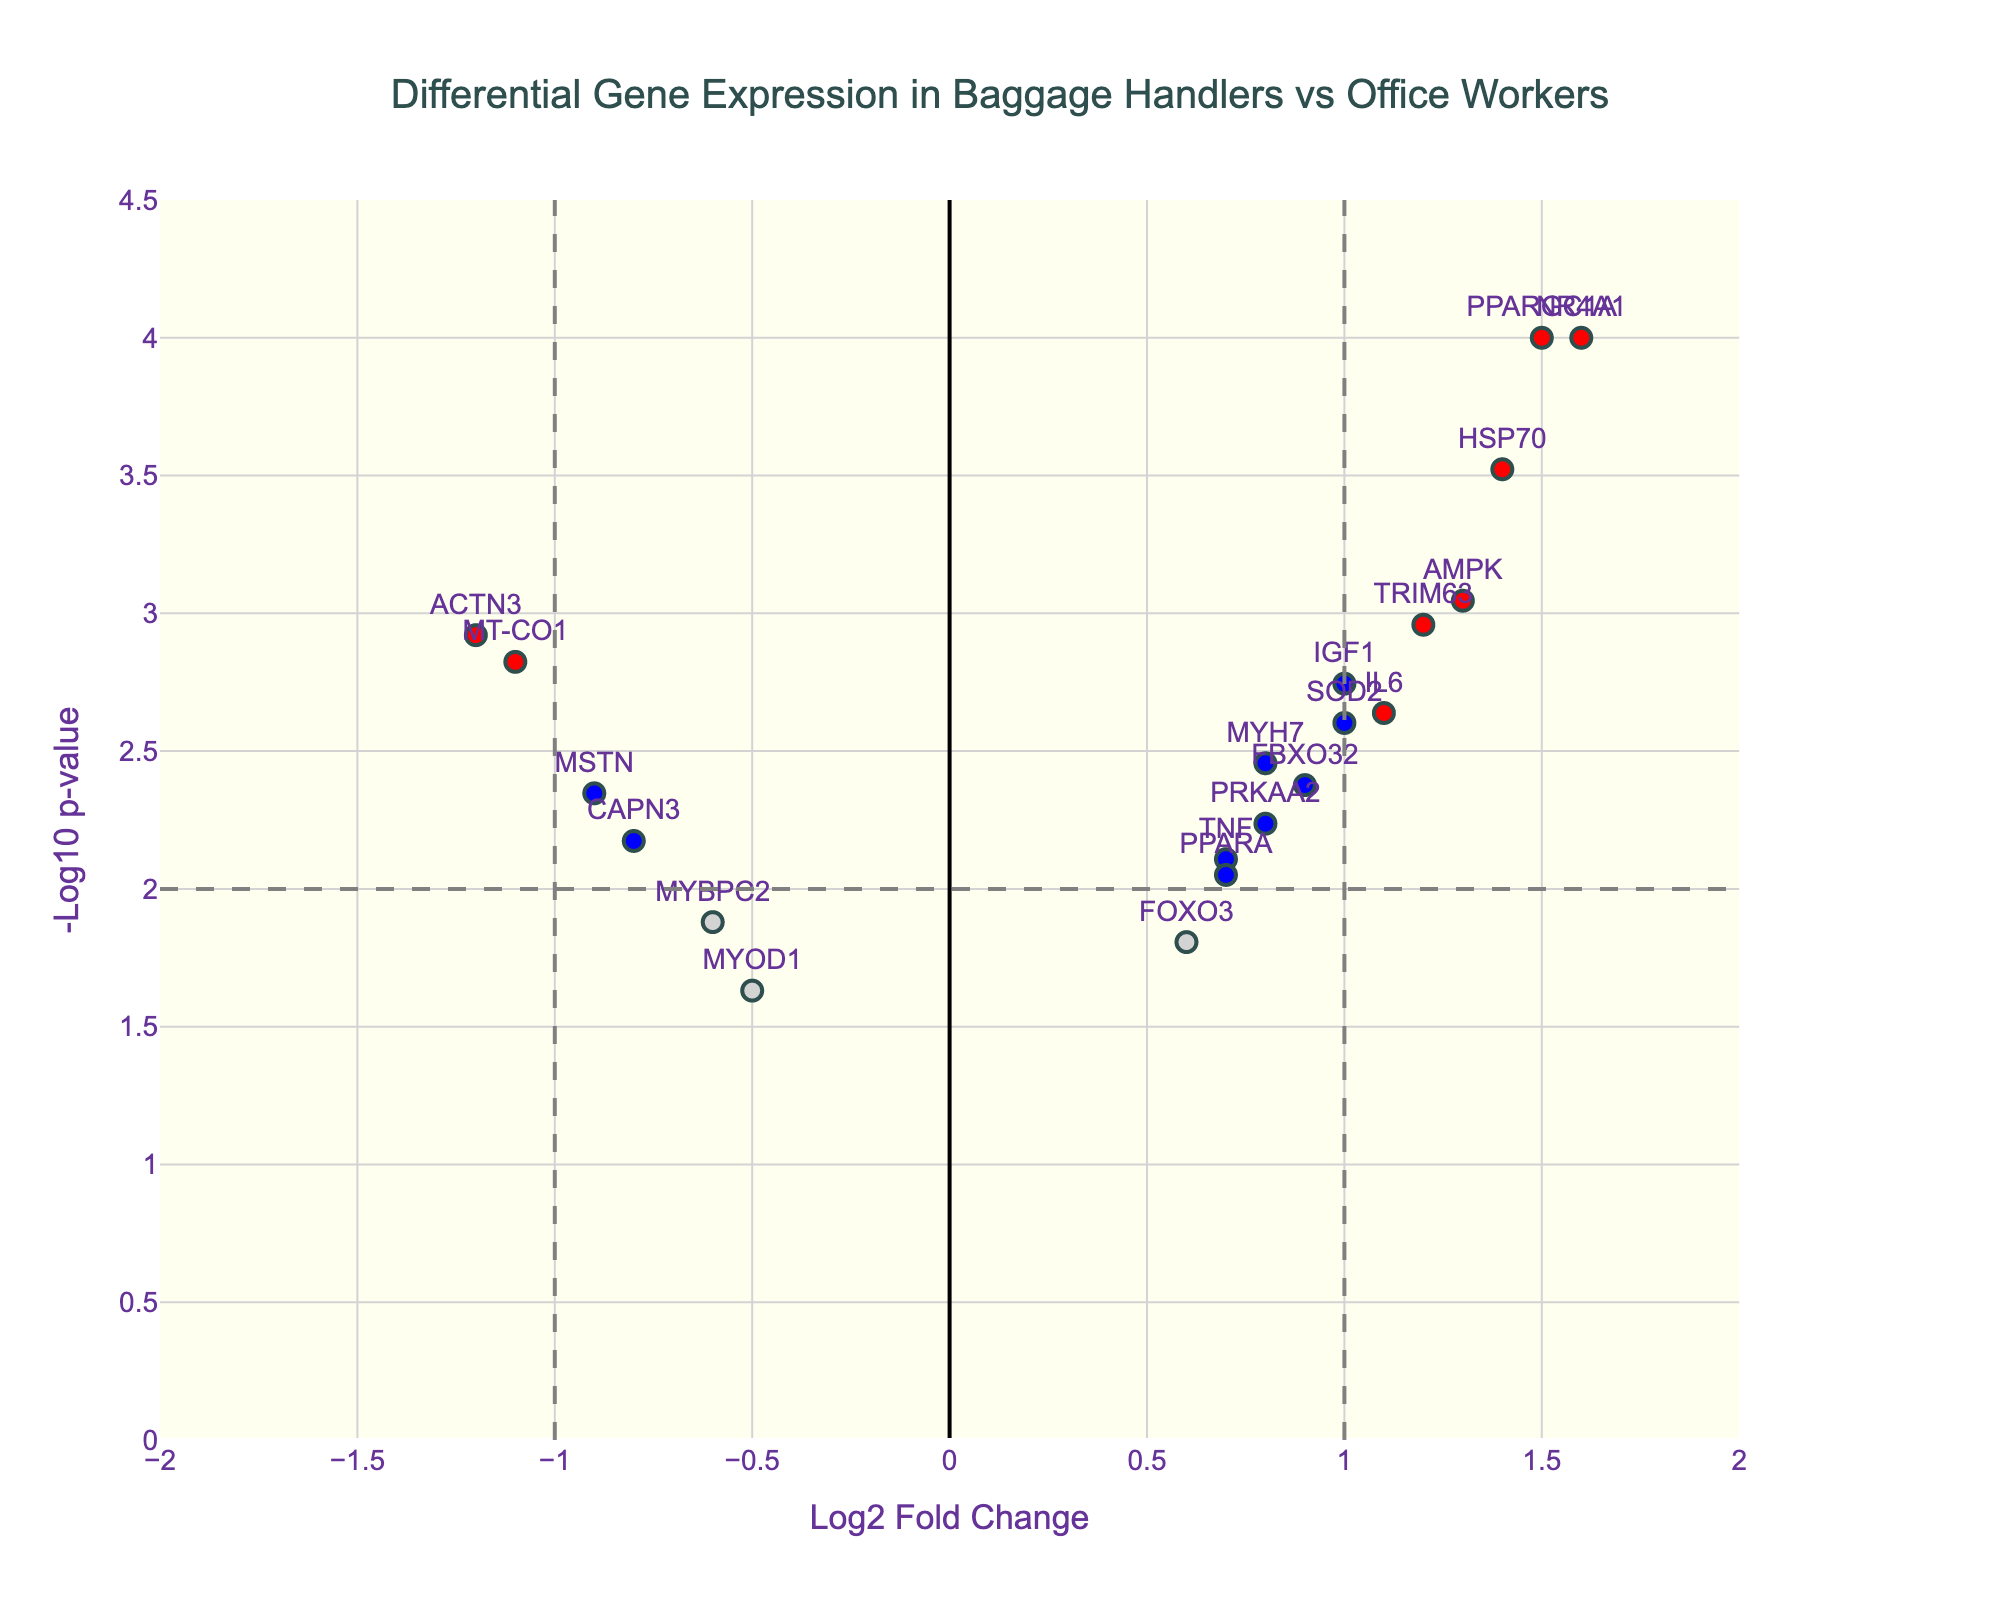How many genes have a p-value less than 0.01? Look for the genes colored in either red or blue, indicating a p-value below 0.01. There are 14 such genes.
Answer: 14 Which gene has the highest fold change? Identify the gene with the largest positive log2 fold change value. NR4A1 has the highest fold change with a value of 1.6.
Answer: NR4A1 What is the log2 fold change of the MYH7 gene? Locate the MYH7 gene and read its log2 fold change value from the chart. The log2 fold change for MYH7 is 0.8.
Answer: 0.8 Which gene appears at the intersection of the -1 log2 fold change line and the -log10 p-value threshold? Check for the gene that intersects the vertical line at log2 fold change = -1 and the horizontal line at -log10 p-value threshold (marked by the dashed lines). MT-CO1 is at this intersection.
Answer: MT-CO1 Are there more genes with positive or negative log2 fold changes? Count the number of data points on the positive side and compare it with the number on the negative side. There are 12 genes with positive log2 fold changes and 8 genes with negative log2 fold changes.
Answer: Positive What is the color code for genes with a significant fold change but a p-value above 0.01? Refer to the explanation for color coding: significant fold change but p-value >= 0.01 is indicated by green.
Answer: Green How many genes have both a log2 fold change greater than 1 and a p-value less than 0.01? Identify the red color-coded genes with a log2 fold change > 1. There are 4 such genes: PPARGC1A, AMPK, HSP70, and NR4A1.
Answer: 4 Which gene has the lowest p-value, and what is its log2 fold change? Find the gene with the highest -log10 p-value (visually the tallest point on the plot). PPARGC1A has the lowest p-value with a log2 fold change of 1.5.
Answer: PPARGC1A; 1.5 How many genes with a p-value less than 0.01 have negative log2 fold changes? Identify genes that meet both conditions: p-value < 0.01 and log2 fold change < 0. There are 3 such genes: ACTN3, MT-CO1, and MSTN.
Answer: 3 